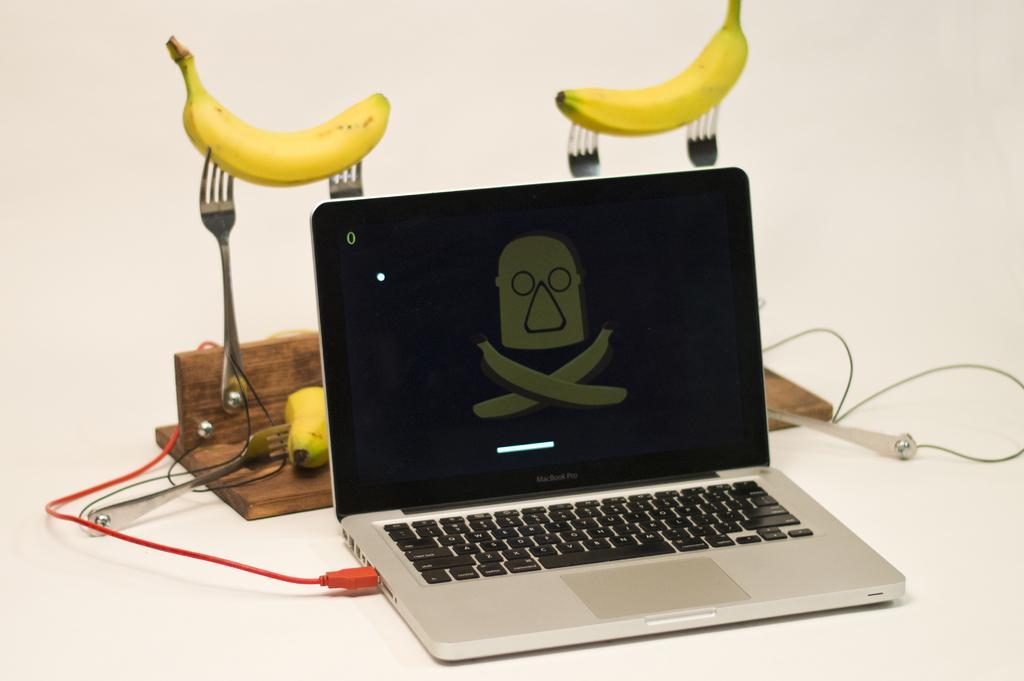Please provide a concise description of this image. There is one laptop kept on a white color surface as we can see at the bottom of this image. We can see bananas, forks and a wooden object is present in the background. 